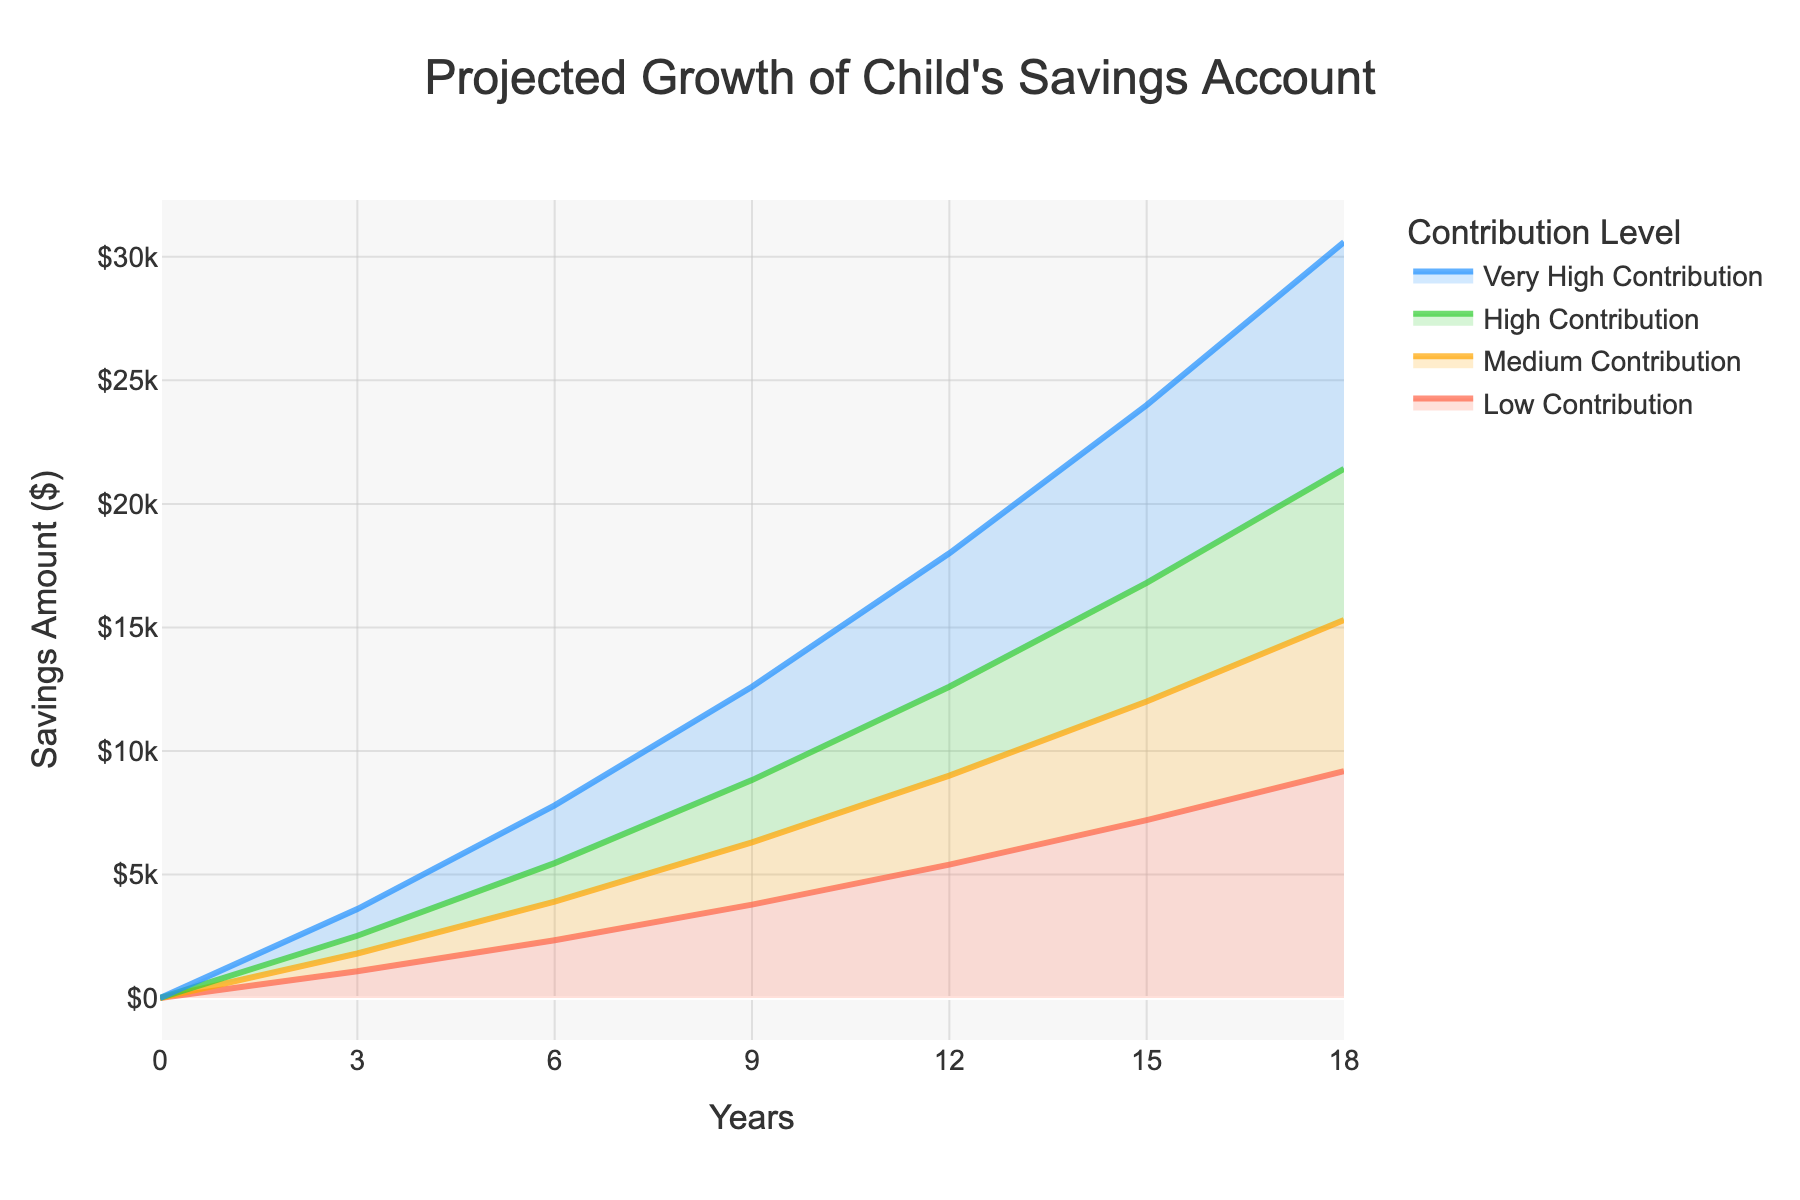what's the title of the chart? The title is usually clearly marked at the top of the figure, and in this case, it describes the main purpose of the chart.
Answer: Projected Growth of Child's Savings Account what is the savings amount after 9 years for the medium contribution level? Locate the medium contribution trace and find the corresponding value at the 9-year mark.
Answer: $6300 how much does the low contribution increase from year 0 to year 3? Subtract the value at year 0 from the value at year 3 for the low contribution trace.
Answer: $1080 which contribution level shows the highest savings amount after 18 years? Compare the values for all contribution levels at the 18-year mark to find the highest.
Answer: Very High Contribution what is the difference in savings amounts between the high and low contribution levels at year 6? Subtract the savings amount of the low contribution level from the high contribution level at the 6-year mark.
Answer: $3120 on average, how much money is added every 3 years for the very high contribution level? Take the savings amount at each 3-year interval and calculate the average of the differences.
Answer: $6120 which contribution level's savings never surpasses $10,000 over the entire 18 years? Check the maximum savings amount for each contribution level and identify which one stays below $10,000.
Answer: Low Contribution how many different contribution levels are displayed in the chart? Count the different traces representing distinct contribution levels.
Answer: 4 how does the medium contribution savings amount in year 12 compare to the very high contribution in year 9? Find the values for the medium contribution in year 12 and the very high contribution in year 9 and compare them.
Answer: The medium contribution in year 12 is higher what can you infer about the relationship between contribution levels and the growth of savings over time? Examine the trend of savings for each contribution level over the 18 years to describe general patterns.
Answer: Higher contribution levels lead to faster and greater growth in savings 